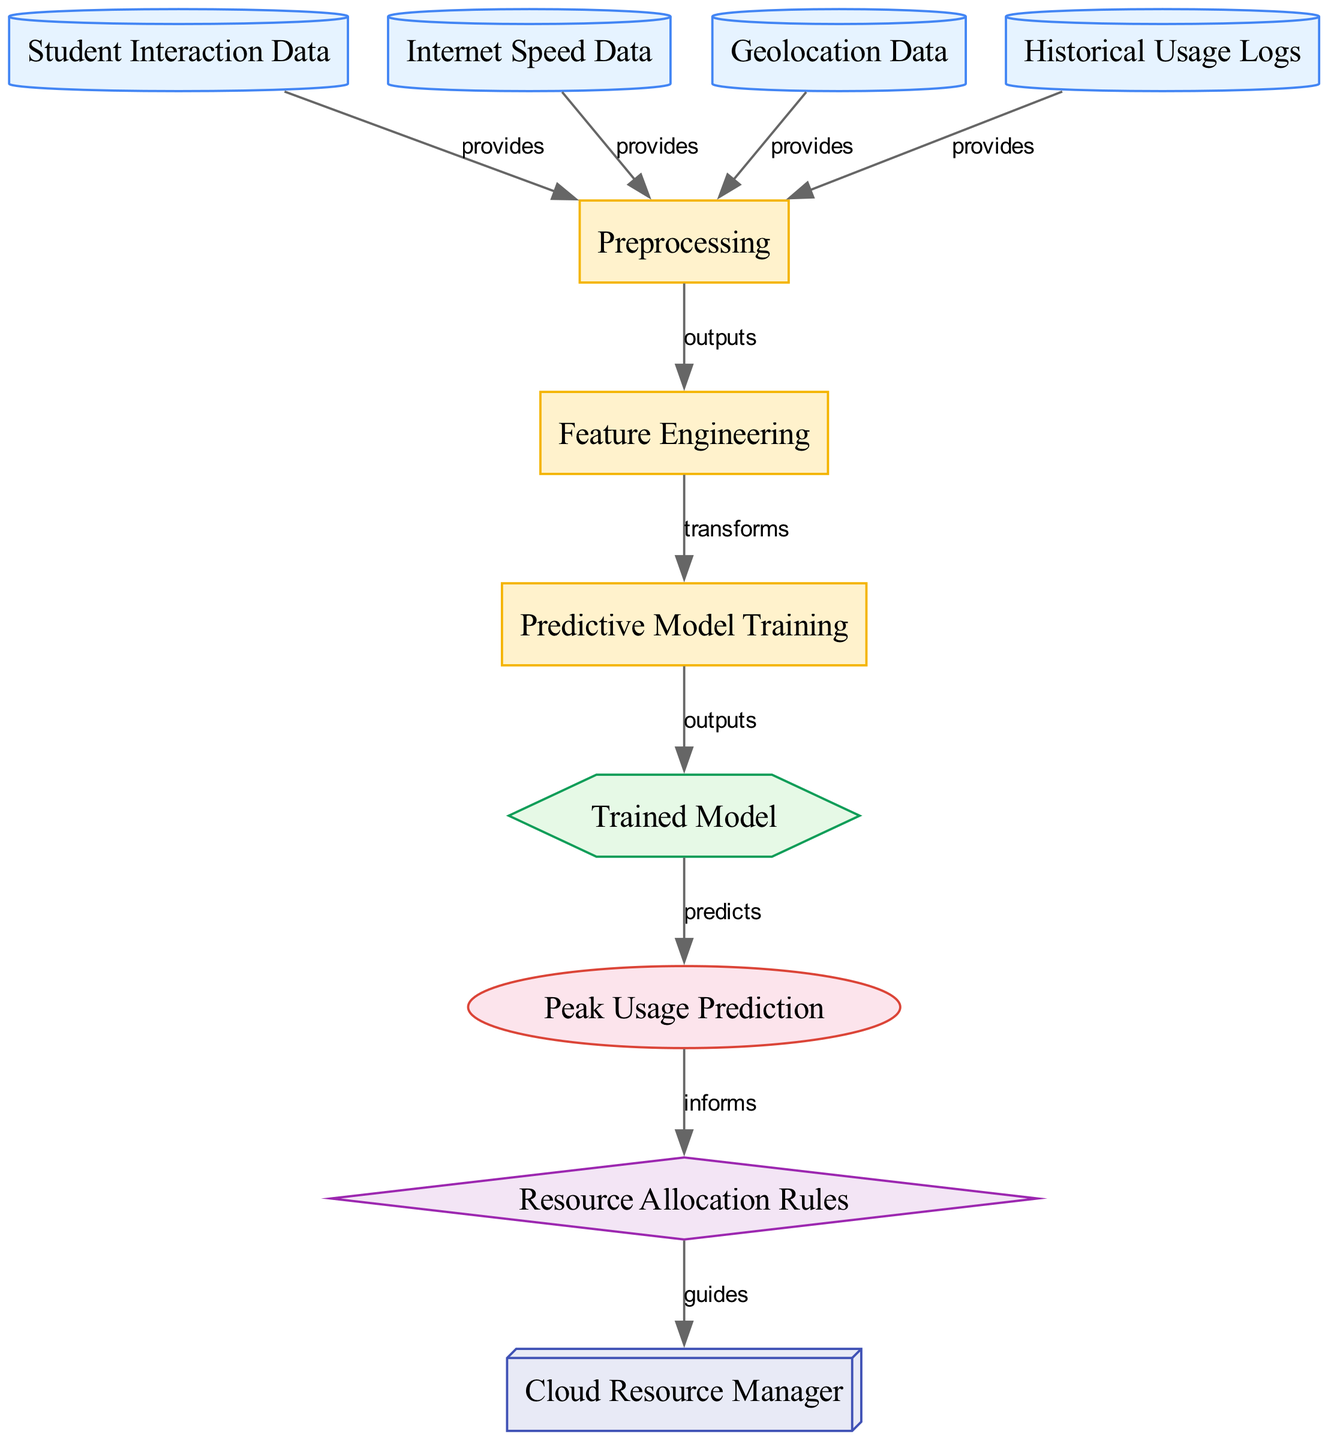What are the input features to the preprocessing stage? The input features to the preprocessing stage are derived from the nodes that feed into it: "Student Interaction Data," "Internet Speed Data," "Geolocation Data," and "Historical Usage Logs." These four data sources provide the necessary information for preprocessing.
Answer: Student Interaction Data, Internet Speed Data, Geolocation Data, Historical Usage Logs How many total nodes are present in the diagram? To find the total number of nodes, we count the distinct nodes listed in the diagram. There are 11 unique nodes representing data sources, processes, models, outputs, rules, and systems.
Answer: 11 What is the output of the "Trained Model"? The "Trained Model" outputs "Peak Usage Prediction." This is the direct output defined in the edges connecting these two nodes in the diagram.
Answer: Peak Usage Prediction What guides the Cloud Resource Manager? The Cloud Resource Manager is guided by the "Resource Allocation Rules." This relationship is shown in the edge connecting these two nodes, indicating that the rules inform the resource manager's decisions.
Answer: Resource Allocation Rules Which process transforms output from preprocessing? The process that transforms the output from preprocessing is "Feature Engineering," as indicated by the directed edge connecting these two nodes.
Answer: Feature Engineering What does "Peak Usage Prediction" inform? "Peak Usage Prediction" informs the "Resource Allocation Rules," meaning it provides necessary data that influence the rules for allocating resources. This is shown in the flow of the diagram.
Answer: Resource Allocation Rules What type of node is "Trained Model"? The "Trained Model" is classified as a "model" node type in the diagram, indicated by its shape and style as specified in the node definitions.
Answer: model What types of data sources are included in the diagram? The diagram includes four types of data sources: "Student Interaction Data," "Internet Speed Data," "Geolocation Data," and "Historical Usage Logs." These label the various types of data used in the resource allocation strategy.
Answer: Student Interaction Data, Internet Speed Data, Geolocation Data, Historical Usage Logs 